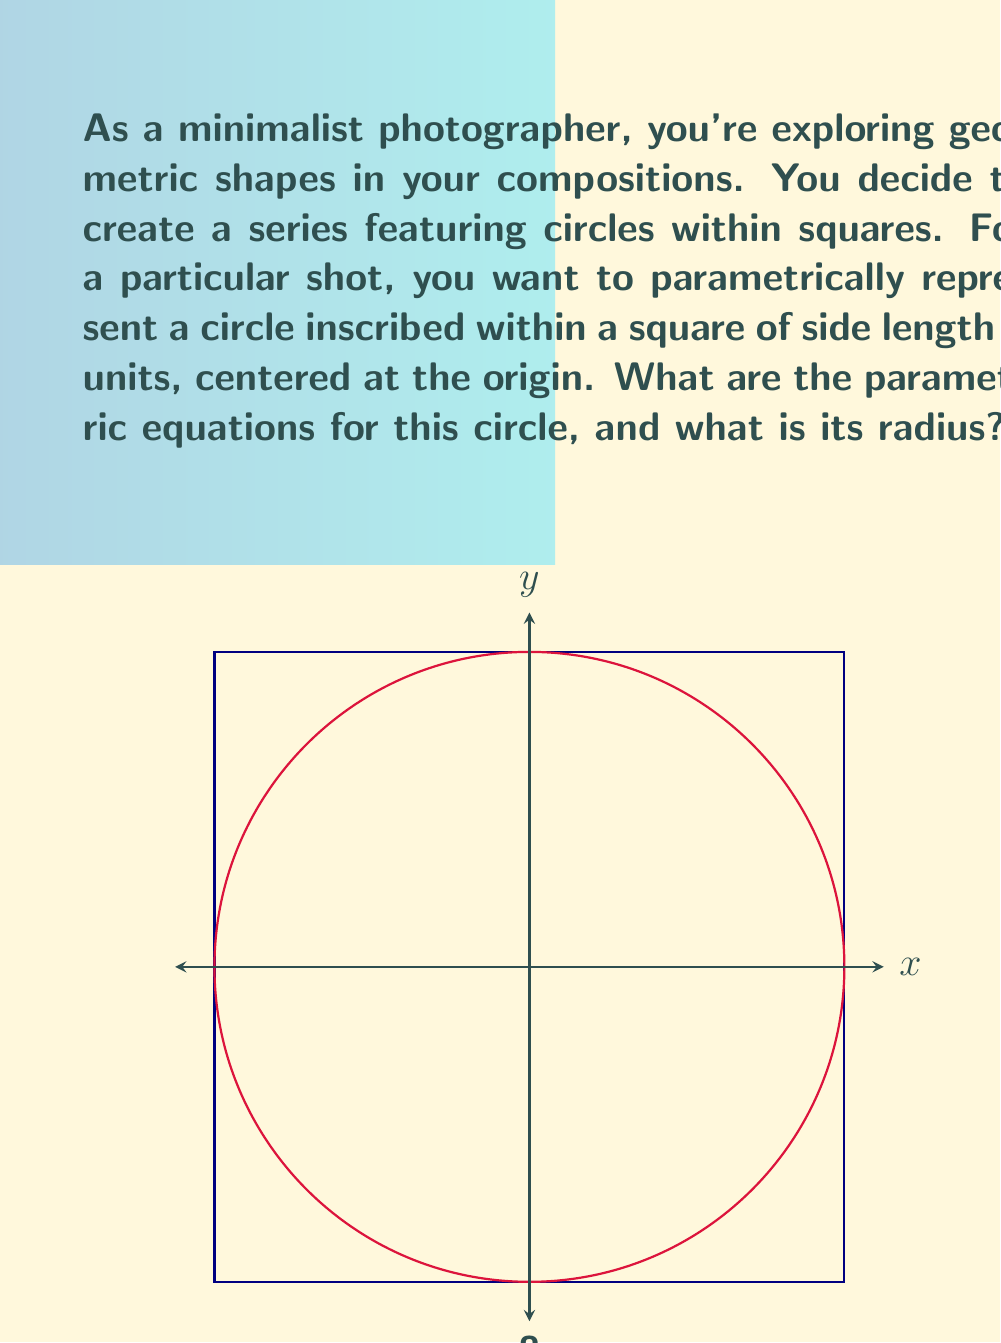Help me with this question. Let's approach this step-by-step:

1) The square is centered at the origin with side length 8. This means its vertices are at (-4,-4), (4,-4), (4,4), and (-4,4).

2) The circle is inscribed in this square, which means it touches all four sides of the square.

3) The radius of the circle will be half the side length of the square:
   $$r = \frac{8}{2} = 4$$

4) The general parametric equations for a circle centered at (h,k) with radius r are:
   $$x = h + r\cos(t)$$
   $$y = k + r\sin(t)$$
   where $t$ is the parameter that varies from 0 to $2\pi$.

5) In our case, the circle is centered at the origin (0,0), so h = 0 and k = 0. The radius r = 4.

6) Substituting these values into the general equations:
   $$x = 0 + 4\cos(t) = 4\cos(t)$$
   $$y = 0 + 4\sin(t) = 4\sin(t)$$

Therefore, the parametric equations for this circle are:
$$x = 4\cos(t)$$
$$y = 4\sin(t)$$
where $0 \leq t < 2\pi$
Answer: $x = 4\cos(t)$, $y = 4\sin(t)$, radius = 4 